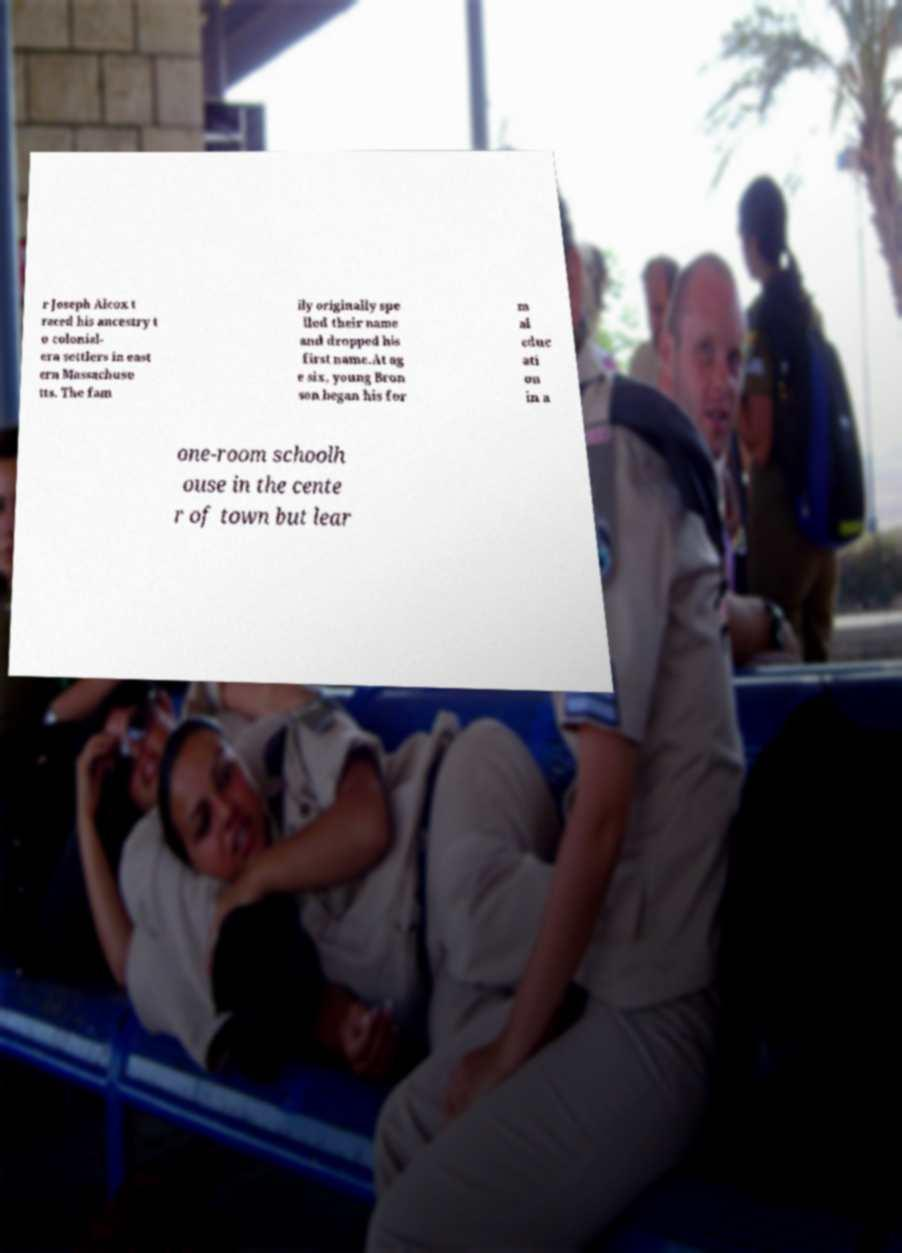Can you read and provide the text displayed in the image?This photo seems to have some interesting text. Can you extract and type it out for me? r Joseph Alcox t raced his ancestry t o colonial- era settlers in east ern Massachuse tts. The fam ily originally spe lled their name and dropped his first name.At ag e six, young Bron son began his for m al educ ati on in a one-room schoolh ouse in the cente r of town but lear 